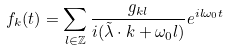Convert formula to latex. <formula><loc_0><loc_0><loc_500><loc_500>f _ { k } ( t ) = \sum _ { l \in { \mathbb { Z } } } \frac { g _ { k l } } { i ( \tilde { \lambda } \cdot k + \omega _ { 0 } l ) } e ^ { i l \omega _ { 0 } t }</formula> 